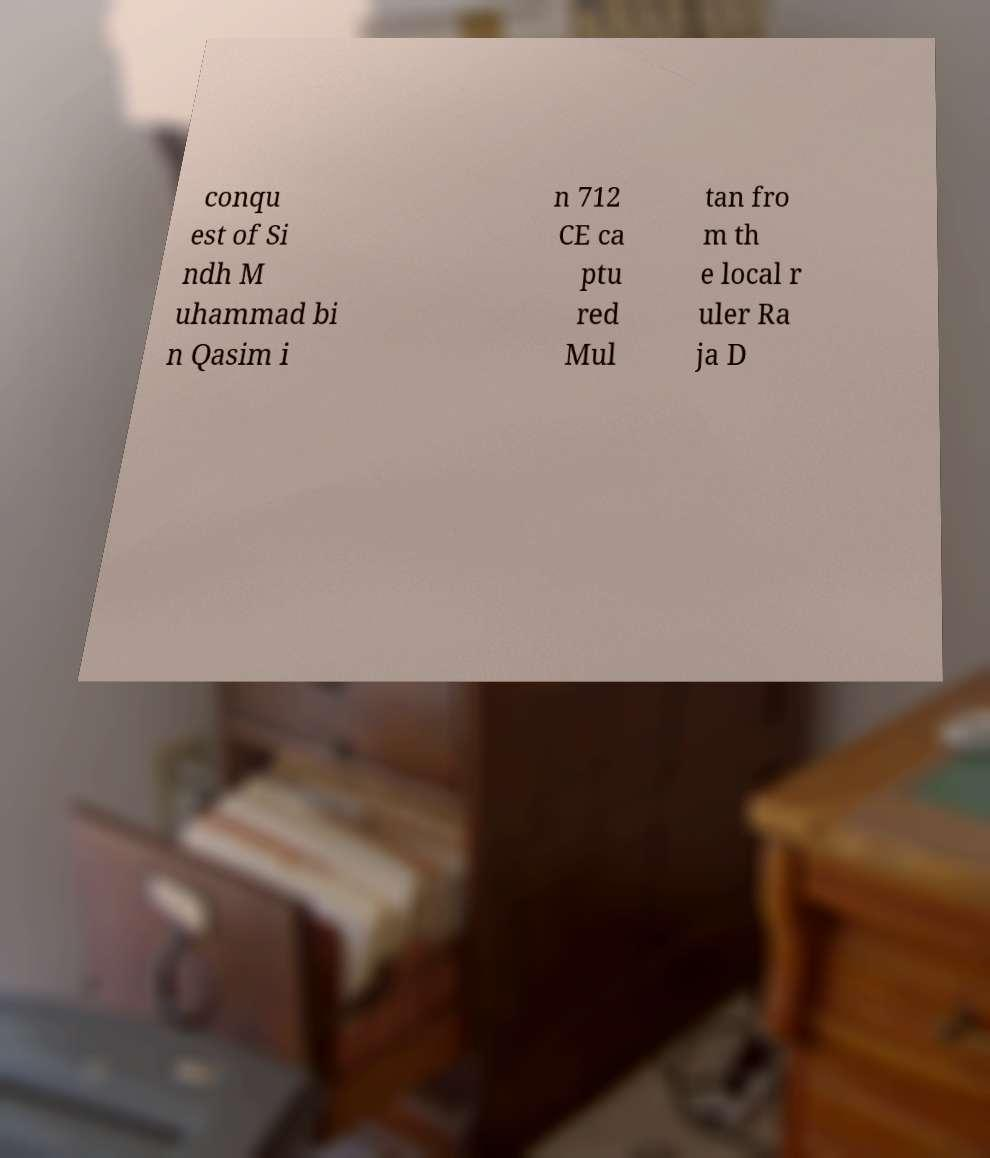Can you accurately transcribe the text from the provided image for me? conqu est of Si ndh M uhammad bi n Qasim i n 712 CE ca ptu red Mul tan fro m th e local r uler Ra ja D 